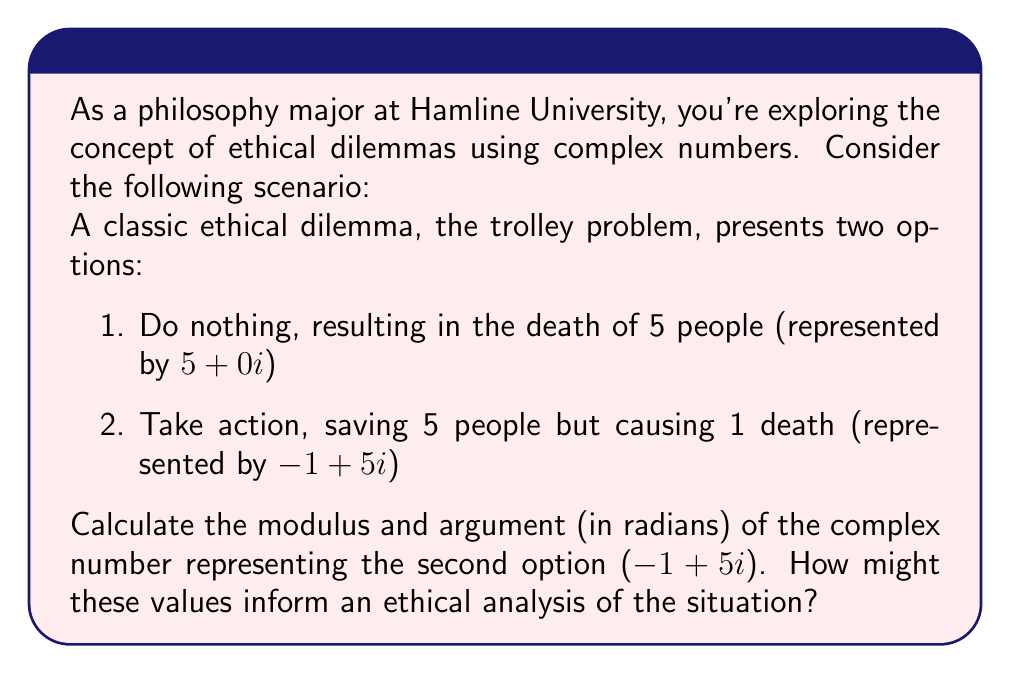Can you answer this question? To solve this problem, we need to calculate the modulus and argument of the complex number $z = -1 + 5i$.

1. Calculating the modulus:
   The modulus of a complex number $z = a + bi$ is given by the formula:
   $$|z| = \sqrt{a^2 + b^2}$$
   
   For our complex number:
   $$|-1 + 5i| = \sqrt{(-1)^2 + 5^2} = \sqrt{1 + 25} = \sqrt{26}$$

2. Calculating the argument:
   The argument of a complex number is the angle it makes with the positive real axis, measured counterclockwise. It can be calculated using the arctangent function:
   $$\arg(z) = \tan^{-1}\left(\frac{b}{a}\right)$$
   
   However, we need to be careful with the quadrant. Since the real part is negative and the imaginary part is positive, we're in the second quadrant. We need to add $\pi$ to the result of arctangent:
   
   $$\arg(-1 + 5i) = \tan^{-1}\left(\frac{5}{-1}\right) + \pi = -\tan^{-1}(5) + \pi$$

   Using a calculator or computer, we can find:
   $$\arg(-1 + 5i) \approx 1.768189 + \pi \approx 4.909581$$

Interpretation:
The modulus $\sqrt{26}$ represents the magnitude of the ethical decision's impact. A larger modulus might indicate a more significant overall effect.

The argument 4.909581 radians (approximately 281.3°) represents the direction or nature of the ethical decision. An angle in the second quadrant could be interpreted as a decision that has both positive (saving lives) and negative (causing a death) consequences.

These mathematical representations could provide a framework for quantifying and comparing different ethical scenarios, although the interpretation and application of these values in ethical reasoning would require careful philosophical consideration.
Answer: Modulus: $\sqrt{26}$
Argument: $4.909581$ radians 